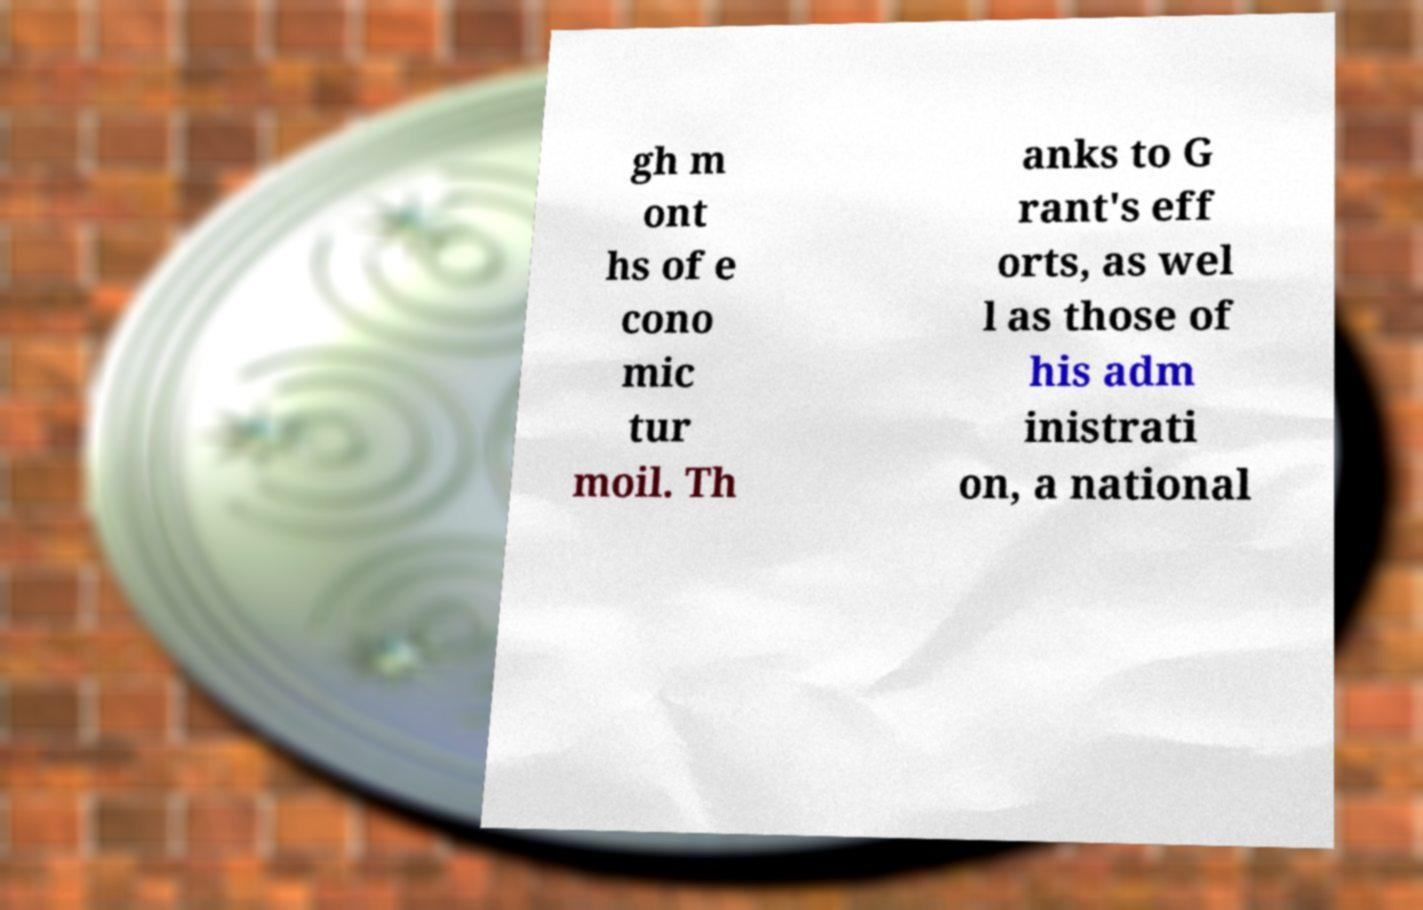Please read and relay the text visible in this image. What does it say? gh m ont hs of e cono mic tur moil. Th anks to G rant's eff orts, as wel l as those of his adm inistrati on, a national 